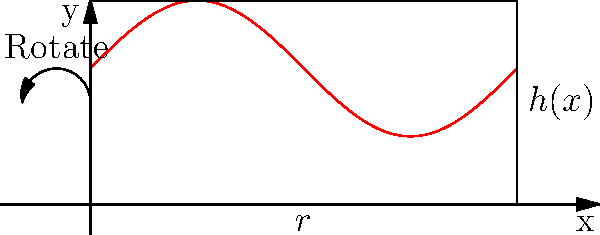As a fashion designer who has worked on Rita Ora's iconic red carpet looks, you're designing a custom cylindrical hat box for her latest avant-garde headpiece. The base radius of the box is $r=10$ cm, and the height varies according to the function $h(x)=20+5\sin(x)$ cm, where $x$ is the angle in radians as the box rotates around its central axis. Calculate the volume of this uniquely shaped hat box. To find the volume of this cylindrical hat box with varying height, we'll use the washer method from calculus. Here's the step-by-step solution:

1) The volume of a solid of revolution is given by the formula:

   $$V = \int_0^{2\pi} \pi r^2 h(x) dx$$

   where $r$ is the radius of the base and $h(x)$ is the height function.

2) We're given $r=10$ cm and $h(x)=20+5\sin(x)$ cm.

3) Substituting these into our volume formula:

   $$V = \int_0^{2\pi} \pi (10)^2 (20+5\sin(x)) dx$$

4) Simplify:

   $$V = 100\pi \int_0^{2\pi} (20+5\sin(x)) dx$$

5) Integrate:

   $$V = 100\pi [20x - 5\cos(x)]_0^{2\pi}$$

6) Evaluate the definite integral:

   $$V = 100\pi [(20(2\pi) - 5\cos(2\pi)) - (20(0) - 5\cos(0))]$$

7) Simplify:

   $$V = 100\pi [40\pi - 5 + 5] = 4000\pi^2$$

8) The final volume is $4000\pi^2$ cubic centimeters.
Answer: $4000\pi^2$ cm³ 